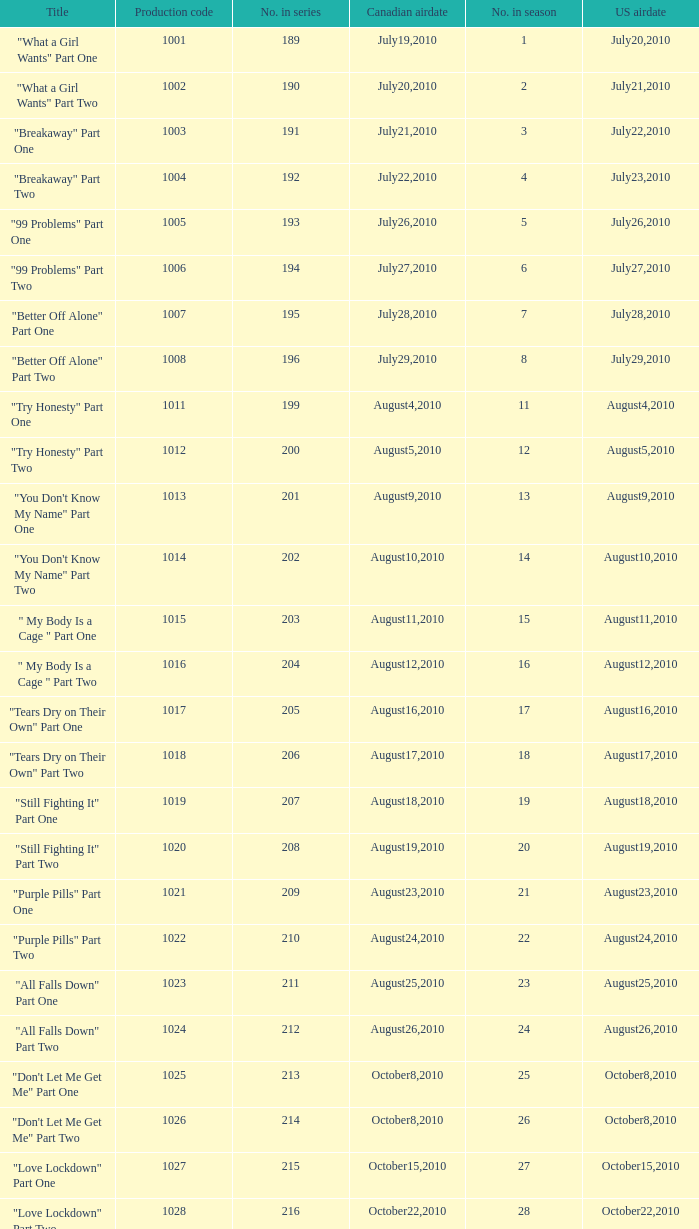What was the us airdate of "love lockdown" part one? October15,2010. 